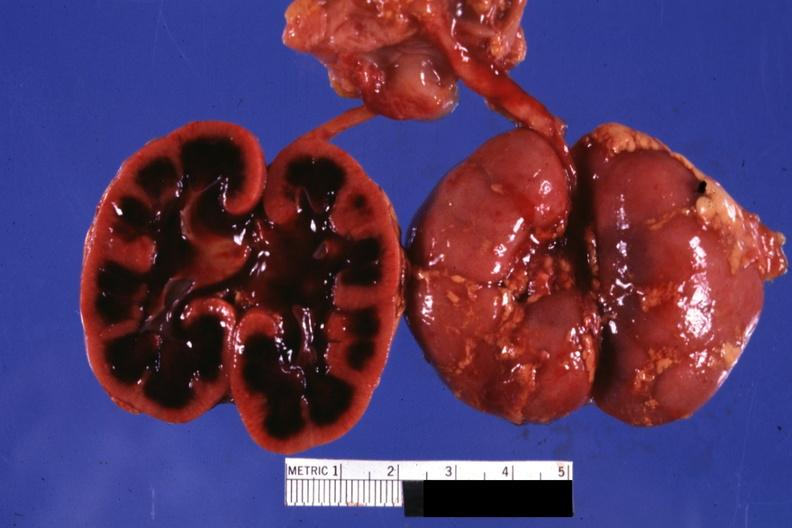s med excellent example of epidermal separation gross of this lesion present?
Answer the question using a single word or phrase. No 